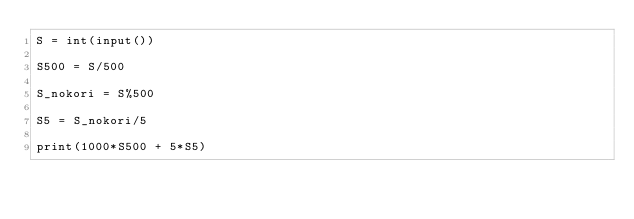<code> <loc_0><loc_0><loc_500><loc_500><_Python_>S = int(input())

S500 = S/500

S_nokori = S%500

S5 = S_nokori/5

print(1000*S500 + 5*S5)</code> 